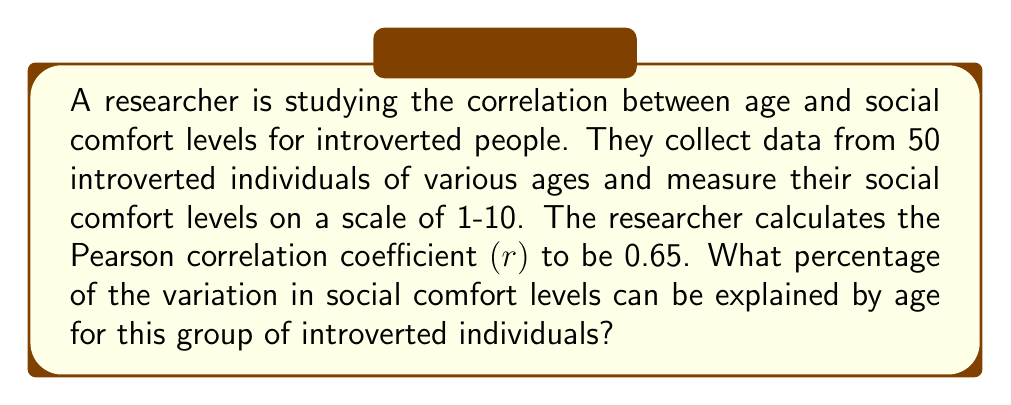Provide a solution to this math problem. To solve this problem, we need to understand the concept of the coefficient of determination, which is derived from the Pearson correlation coefficient.

1. The Pearson correlation coefficient (r) measures the strength and direction of the linear relationship between two variables. In this case, r = 0.65.

2. The coefficient of determination, denoted as $R^2$, represents the proportion of variance in the dependent variable (social comfort levels) that is predictable from the independent variable (age).

3. The formula for the coefficient of determination is:

   $$R^2 = r^2$$

   where r is the Pearson correlation coefficient.

4. Calculate $R^2$:
   $$R^2 = (0.65)^2 = 0.4225$$

5. To express this as a percentage, multiply by 100:
   $$0.4225 \times 100 = 42.25\%$$

This means that 42.25% of the variation in social comfort levels can be explained by age for this group of introverted individuals.
Answer: 42.25% 